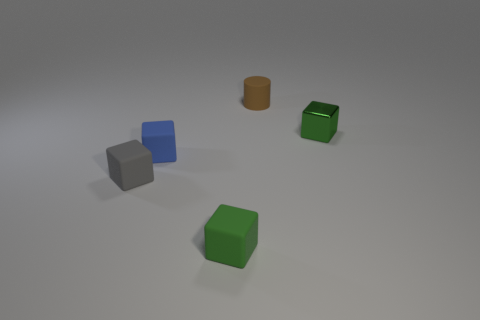Subtract all rubber blocks. How many blocks are left? 1 Add 4 gray blocks. How many objects exist? 9 Subtract all blue cubes. How many cubes are left? 3 Subtract all blocks. How many objects are left? 1 Subtract 2 blocks. How many blocks are left? 2 Subtract all yellow cylinders. How many red blocks are left? 0 Subtract 1 green blocks. How many objects are left? 4 Subtract all red cylinders. Subtract all gray spheres. How many cylinders are left? 1 Subtract all small blue metallic cylinders. Subtract all cubes. How many objects are left? 1 Add 1 cylinders. How many cylinders are left? 2 